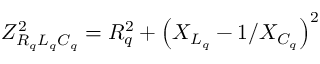Convert formula to latex. <formula><loc_0><loc_0><loc_500><loc_500>Z _ { R _ { q } L _ { q } C _ { q } } ^ { 2 } = R _ { q } ^ { 2 } + \left ( X _ { L _ { q } } - 1 / X _ { C _ { q } } \right ) ^ { 2 }</formula> 